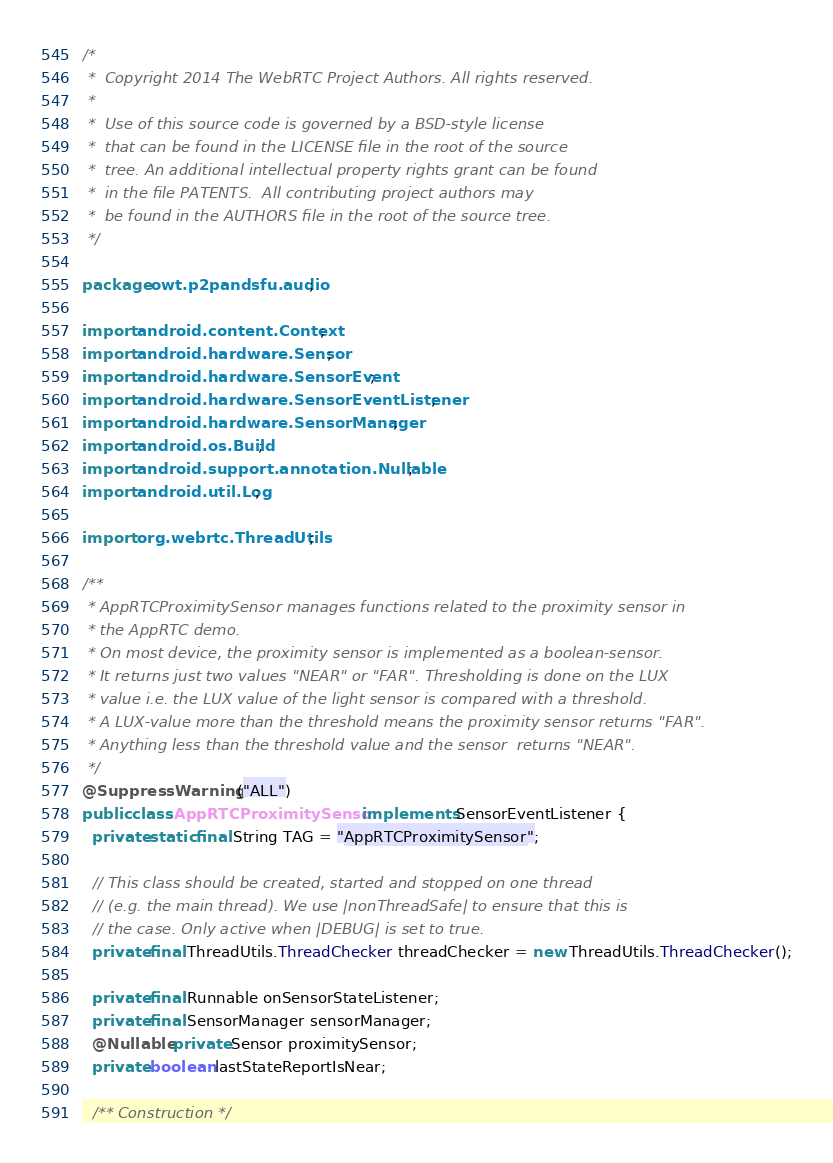Convert code to text. <code><loc_0><loc_0><loc_500><loc_500><_Java_>/*
 *  Copyright 2014 The WebRTC Project Authors. All rights reserved.
 *
 *  Use of this source code is governed by a BSD-style license
 *  that can be found in the LICENSE file in the root of the source
 *  tree. An additional intellectual property rights grant can be found
 *  in the file PATENTS.  All contributing project authors may
 *  be found in the AUTHORS file in the root of the source tree.
 */

package owt.p2pandsfu.audio;

import android.content.Context;
import android.hardware.Sensor;
import android.hardware.SensorEvent;
import android.hardware.SensorEventListener;
import android.hardware.SensorManager;
import android.os.Build;
import android.support.annotation.Nullable;
import android.util.Log;

import org.webrtc.ThreadUtils;

/**
 * AppRTCProximitySensor manages functions related to the proximity sensor in
 * the AppRTC demo.
 * On most device, the proximity sensor is implemented as a boolean-sensor.
 * It returns just two values "NEAR" or "FAR". Thresholding is done on the LUX
 * value i.e. the LUX value of the light sensor is compared with a threshold.
 * A LUX-value more than the threshold means the proximity sensor returns "FAR".
 * Anything less than the threshold value and the sensor  returns "NEAR".
 */
@SuppressWarnings("ALL")
public class AppRTCProximitySensor implements SensorEventListener {
  private static final String TAG = "AppRTCProximitySensor";

  // This class should be created, started and stopped on one thread
  // (e.g. the main thread). We use |nonThreadSafe| to ensure that this is
  // the case. Only active when |DEBUG| is set to true.
  private final ThreadUtils.ThreadChecker threadChecker = new ThreadUtils.ThreadChecker();

  private final Runnable onSensorStateListener;
  private final SensorManager sensorManager;
  @Nullable private Sensor proximitySensor;
  private boolean lastStateReportIsNear;

  /** Construction */</code> 